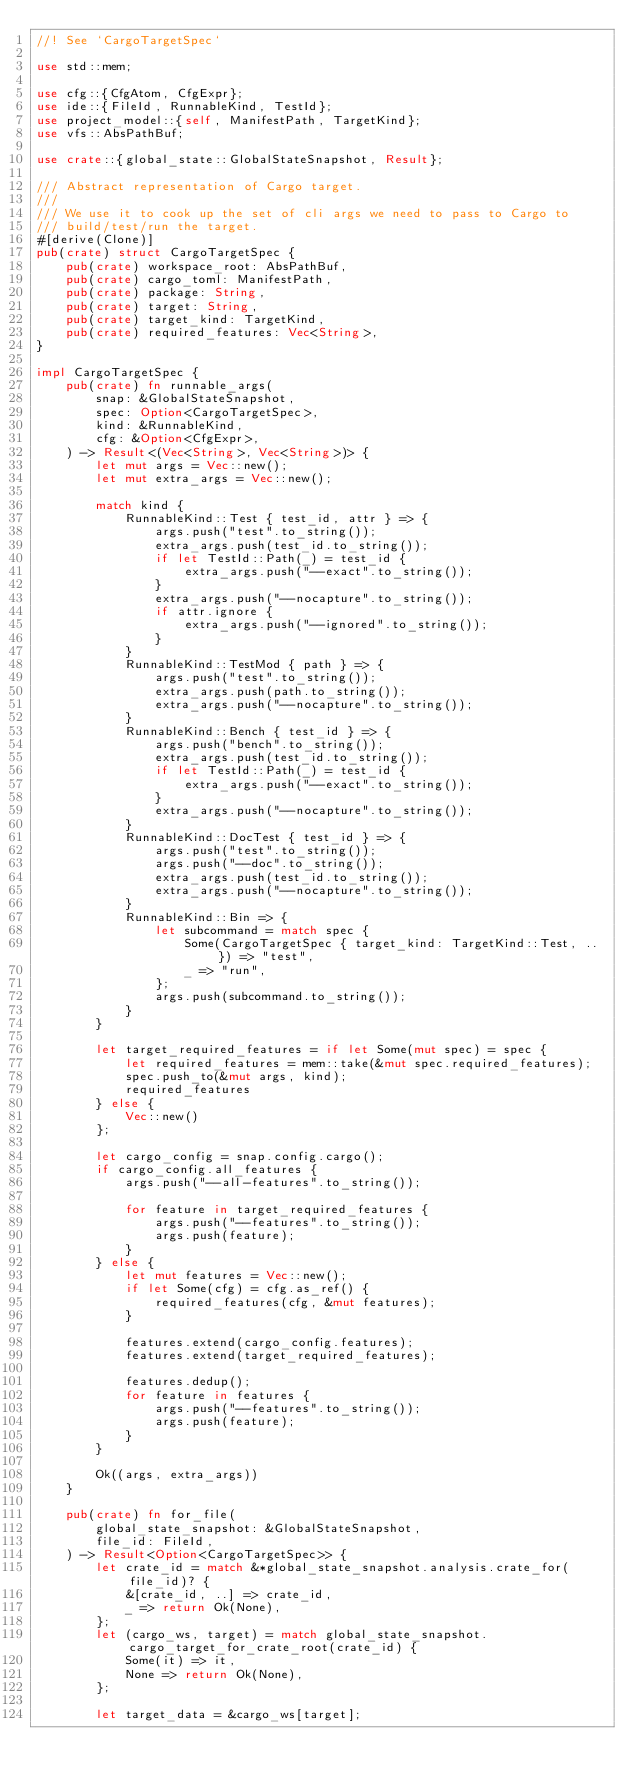<code> <loc_0><loc_0><loc_500><loc_500><_Rust_>//! See `CargoTargetSpec`

use std::mem;

use cfg::{CfgAtom, CfgExpr};
use ide::{FileId, RunnableKind, TestId};
use project_model::{self, ManifestPath, TargetKind};
use vfs::AbsPathBuf;

use crate::{global_state::GlobalStateSnapshot, Result};

/// Abstract representation of Cargo target.
///
/// We use it to cook up the set of cli args we need to pass to Cargo to
/// build/test/run the target.
#[derive(Clone)]
pub(crate) struct CargoTargetSpec {
    pub(crate) workspace_root: AbsPathBuf,
    pub(crate) cargo_toml: ManifestPath,
    pub(crate) package: String,
    pub(crate) target: String,
    pub(crate) target_kind: TargetKind,
    pub(crate) required_features: Vec<String>,
}

impl CargoTargetSpec {
    pub(crate) fn runnable_args(
        snap: &GlobalStateSnapshot,
        spec: Option<CargoTargetSpec>,
        kind: &RunnableKind,
        cfg: &Option<CfgExpr>,
    ) -> Result<(Vec<String>, Vec<String>)> {
        let mut args = Vec::new();
        let mut extra_args = Vec::new();

        match kind {
            RunnableKind::Test { test_id, attr } => {
                args.push("test".to_string());
                extra_args.push(test_id.to_string());
                if let TestId::Path(_) = test_id {
                    extra_args.push("--exact".to_string());
                }
                extra_args.push("--nocapture".to_string());
                if attr.ignore {
                    extra_args.push("--ignored".to_string());
                }
            }
            RunnableKind::TestMod { path } => {
                args.push("test".to_string());
                extra_args.push(path.to_string());
                extra_args.push("--nocapture".to_string());
            }
            RunnableKind::Bench { test_id } => {
                args.push("bench".to_string());
                extra_args.push(test_id.to_string());
                if let TestId::Path(_) = test_id {
                    extra_args.push("--exact".to_string());
                }
                extra_args.push("--nocapture".to_string());
            }
            RunnableKind::DocTest { test_id } => {
                args.push("test".to_string());
                args.push("--doc".to_string());
                extra_args.push(test_id.to_string());
                extra_args.push("--nocapture".to_string());
            }
            RunnableKind::Bin => {
                let subcommand = match spec {
                    Some(CargoTargetSpec { target_kind: TargetKind::Test, .. }) => "test",
                    _ => "run",
                };
                args.push(subcommand.to_string());
            }
        }

        let target_required_features = if let Some(mut spec) = spec {
            let required_features = mem::take(&mut spec.required_features);
            spec.push_to(&mut args, kind);
            required_features
        } else {
            Vec::new()
        };

        let cargo_config = snap.config.cargo();
        if cargo_config.all_features {
            args.push("--all-features".to_string());

            for feature in target_required_features {
                args.push("--features".to_string());
                args.push(feature);
            }
        } else {
            let mut features = Vec::new();
            if let Some(cfg) = cfg.as_ref() {
                required_features(cfg, &mut features);
            }

            features.extend(cargo_config.features);
            features.extend(target_required_features);

            features.dedup();
            for feature in features {
                args.push("--features".to_string());
                args.push(feature);
            }
        }

        Ok((args, extra_args))
    }

    pub(crate) fn for_file(
        global_state_snapshot: &GlobalStateSnapshot,
        file_id: FileId,
    ) -> Result<Option<CargoTargetSpec>> {
        let crate_id = match &*global_state_snapshot.analysis.crate_for(file_id)? {
            &[crate_id, ..] => crate_id,
            _ => return Ok(None),
        };
        let (cargo_ws, target) = match global_state_snapshot.cargo_target_for_crate_root(crate_id) {
            Some(it) => it,
            None => return Ok(None),
        };

        let target_data = &cargo_ws[target];</code> 